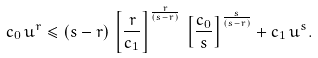<formula> <loc_0><loc_0><loc_500><loc_500>c _ { 0 } \, u ^ { r } \leq ( s - r ) \, \left [ \frac { r } { c _ { 1 } } \right ] ^ { \frac { r } { ( s - r ) } } \, \left [ \frac { c _ { 0 } } { s } \right ] ^ { \frac { s } { ( s - r ) } } + c _ { 1 } \, u ^ { s } .</formula> 